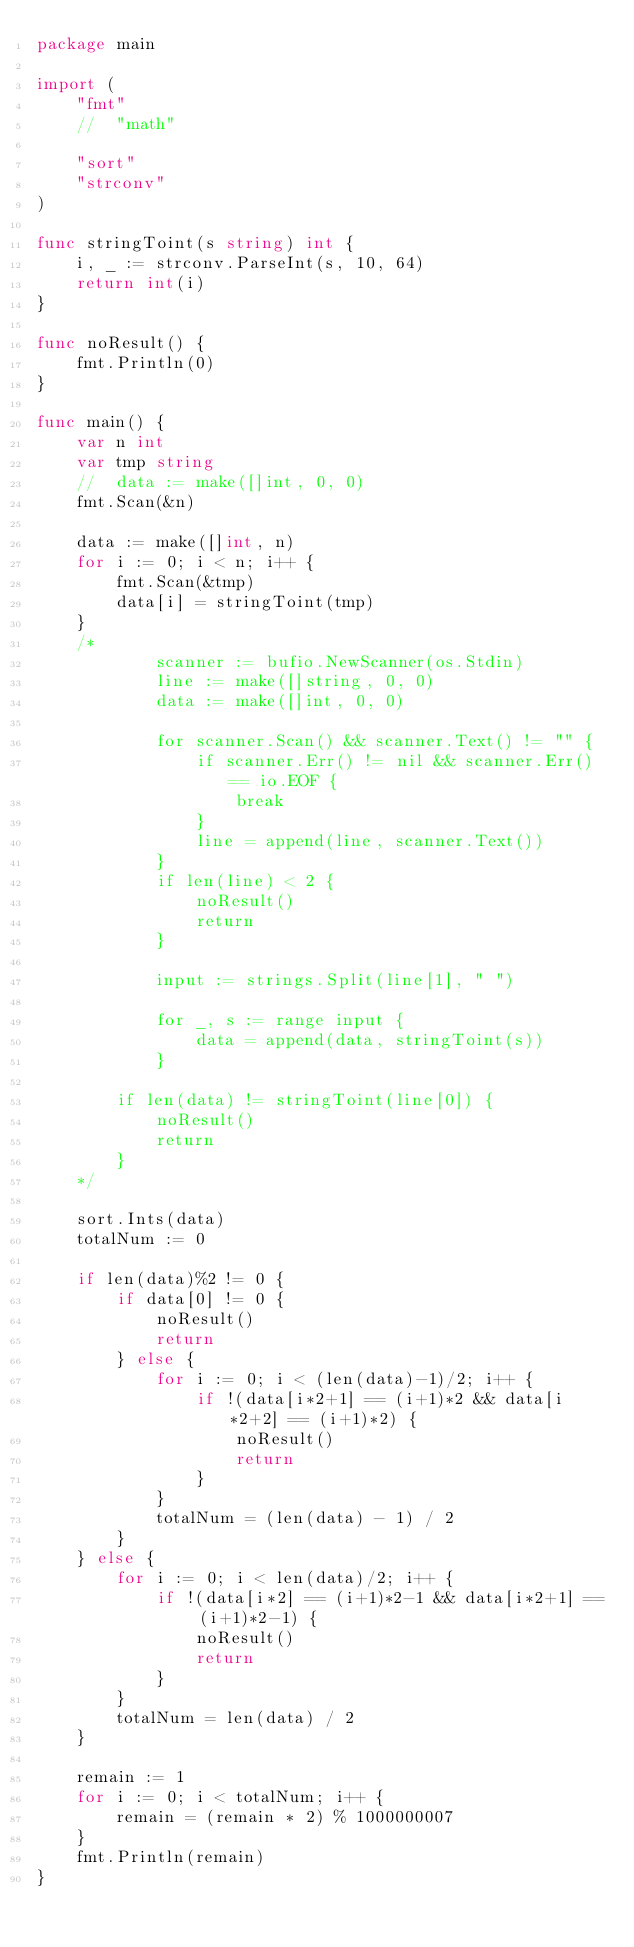<code> <loc_0><loc_0><loc_500><loc_500><_Go_>package main

import (
	"fmt"
	//	"math"

	"sort"
	"strconv"
)

func stringToint(s string) int {
	i, _ := strconv.ParseInt(s, 10, 64)
	return int(i)
}

func noResult() {
	fmt.Println(0)
}

func main() {
	var n int
	var tmp string
	//	data := make([]int, 0, 0)
	fmt.Scan(&n)

	data := make([]int, n)
	for i := 0; i < n; i++ {
		fmt.Scan(&tmp)
		data[i] = stringToint(tmp)
	}
	/*
			scanner := bufio.NewScanner(os.Stdin)
			line := make([]string, 0, 0)
			data := make([]int, 0, 0)

			for scanner.Scan() && scanner.Text() != "" {
				if scanner.Err() != nil && scanner.Err() == io.EOF {
					break
				}
				line = append(line, scanner.Text())
			}
			if len(line) < 2 {
				noResult()
				return
			}

			input := strings.Split(line[1], " ")

			for _, s := range input {
				data = append(data, stringToint(s))
			}

		if len(data) != stringToint(line[0]) {
			noResult()
			return
		}
	*/

	sort.Ints(data)
	totalNum := 0

	if len(data)%2 != 0 {
		if data[0] != 0 {
			noResult()
			return
		} else {
			for i := 0; i < (len(data)-1)/2; i++ {
				if !(data[i*2+1] == (i+1)*2 && data[i*2+2] == (i+1)*2) {
					noResult()
					return
				}
			}
			totalNum = (len(data) - 1) / 2
		}
	} else {
		for i := 0; i < len(data)/2; i++ {
			if !(data[i*2] == (i+1)*2-1 && data[i*2+1] == (i+1)*2-1) {
				noResult()
				return
			}
		}
		totalNum = len(data) / 2
	}

	remain := 1
	for i := 0; i < totalNum; i++ {
		remain = (remain * 2) % 1000000007
	}
	fmt.Println(remain)
}</code> 